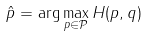<formula> <loc_0><loc_0><loc_500><loc_500>\hat { p } = \arg \max _ { { p } \in { \mathcal { P } } } H ( { p } , { q } )</formula> 